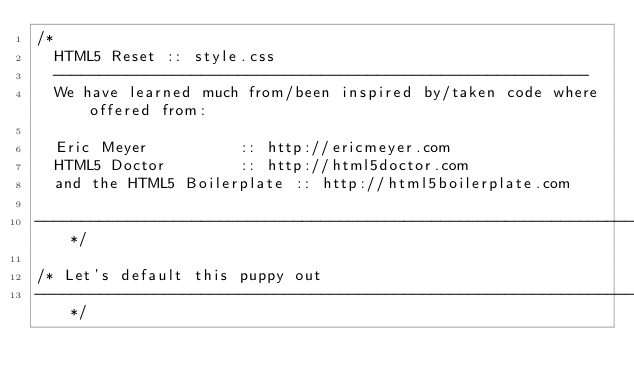Convert code to text. <code><loc_0><loc_0><loc_500><loc_500><_CSS_>/*
	HTML5 Reset :: style.css
	----------------------------------------------------------
	We have learned much from/been inspired by/taken code where offered from:
	
	Eric Meyer					:: http://ericmeyer.com
	HTML5 Doctor				:: http://html5doctor.com
	and the HTML5 Boilerplate	:: http://html5boilerplate.com
	
-------------------------------------------------------------------------------*/

/* Let's default this puppy out
-------------------------------------------------------------------------------*/
</code> 